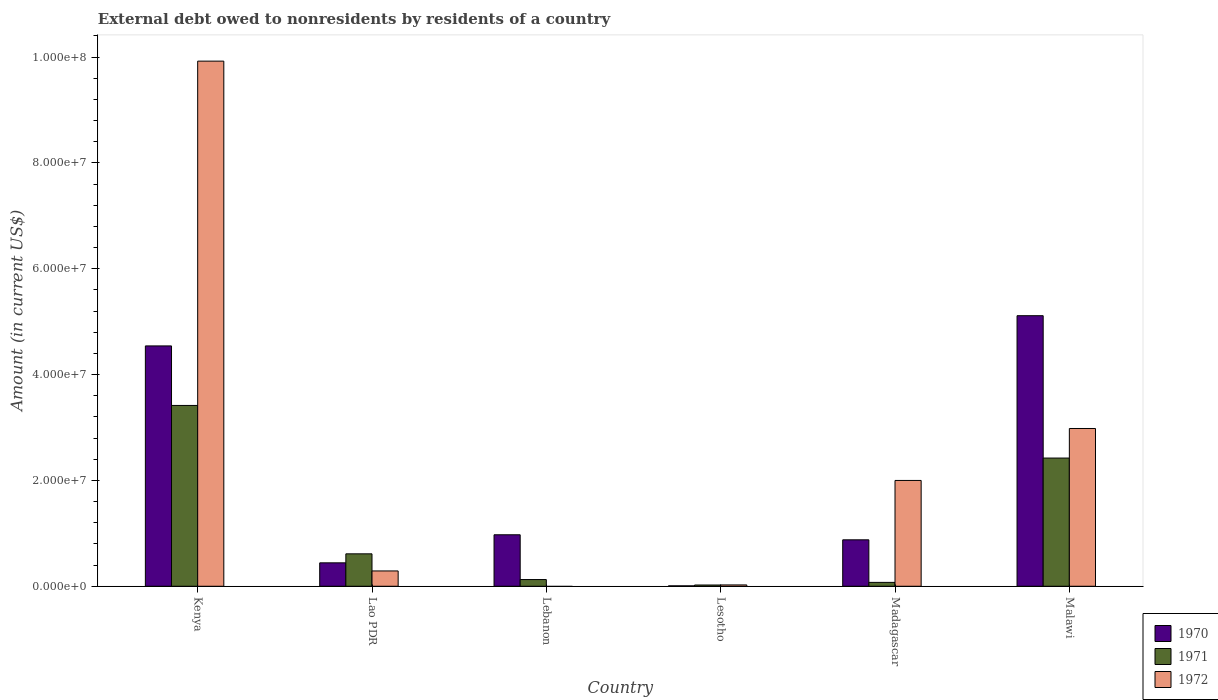Are the number of bars per tick equal to the number of legend labels?
Your answer should be compact. No. Are the number of bars on each tick of the X-axis equal?
Your answer should be compact. No. How many bars are there on the 6th tick from the left?
Offer a very short reply. 3. What is the label of the 5th group of bars from the left?
Your answer should be very brief. Madagascar. What is the external debt owed by residents in 1971 in Malawi?
Your answer should be compact. 2.42e+07. Across all countries, what is the maximum external debt owed by residents in 1972?
Your answer should be compact. 9.92e+07. Across all countries, what is the minimum external debt owed by residents in 1972?
Ensure brevity in your answer.  0. In which country was the external debt owed by residents in 1971 maximum?
Provide a short and direct response. Kenya. What is the total external debt owed by residents in 1972 in the graph?
Offer a terse response. 1.52e+08. What is the difference between the external debt owed by residents in 1970 in Lao PDR and that in Lesotho?
Offer a terse response. 4.35e+06. What is the difference between the external debt owed by residents in 1970 in Lebanon and the external debt owed by residents in 1971 in Lao PDR?
Offer a terse response. 3.60e+06. What is the average external debt owed by residents in 1970 per country?
Your answer should be very brief. 1.99e+07. What is the difference between the external debt owed by residents of/in 1972 and external debt owed by residents of/in 1970 in Malawi?
Offer a terse response. -2.13e+07. In how many countries, is the external debt owed by residents in 1971 greater than 96000000 US$?
Make the answer very short. 0. What is the ratio of the external debt owed by residents in 1971 in Lao PDR to that in Lebanon?
Offer a very short reply. 4.84. Is the external debt owed by residents in 1971 in Madagascar less than that in Malawi?
Keep it short and to the point. Yes. Is the difference between the external debt owed by residents in 1972 in Lao PDR and Malawi greater than the difference between the external debt owed by residents in 1970 in Lao PDR and Malawi?
Offer a very short reply. Yes. What is the difference between the highest and the second highest external debt owed by residents in 1972?
Provide a succinct answer. 6.94e+07. What is the difference between the highest and the lowest external debt owed by residents in 1971?
Your answer should be very brief. 3.39e+07. In how many countries, is the external debt owed by residents in 1972 greater than the average external debt owed by residents in 1972 taken over all countries?
Your answer should be compact. 2. Is the sum of the external debt owed by residents in 1971 in Lesotho and Malawi greater than the maximum external debt owed by residents in 1972 across all countries?
Make the answer very short. No. Is it the case that in every country, the sum of the external debt owed by residents in 1972 and external debt owed by residents in 1970 is greater than the external debt owed by residents in 1971?
Your answer should be very brief. Yes. How many bars are there?
Your response must be concise. 17. What is the difference between two consecutive major ticks on the Y-axis?
Your answer should be very brief. 2.00e+07. Are the values on the major ticks of Y-axis written in scientific E-notation?
Ensure brevity in your answer.  Yes. Does the graph contain any zero values?
Ensure brevity in your answer.  Yes. How are the legend labels stacked?
Offer a very short reply. Vertical. What is the title of the graph?
Your response must be concise. External debt owed to nonresidents by residents of a country. What is the label or title of the X-axis?
Offer a terse response. Country. What is the label or title of the Y-axis?
Make the answer very short. Amount (in current US$). What is the Amount (in current US$) of 1970 in Kenya?
Ensure brevity in your answer.  4.54e+07. What is the Amount (in current US$) in 1971 in Kenya?
Offer a terse response. 3.42e+07. What is the Amount (in current US$) of 1972 in Kenya?
Offer a very short reply. 9.92e+07. What is the Amount (in current US$) of 1970 in Lao PDR?
Provide a short and direct response. 4.42e+06. What is the Amount (in current US$) in 1971 in Lao PDR?
Your answer should be very brief. 6.12e+06. What is the Amount (in current US$) of 1972 in Lao PDR?
Provide a short and direct response. 2.89e+06. What is the Amount (in current US$) in 1970 in Lebanon?
Give a very brief answer. 9.73e+06. What is the Amount (in current US$) in 1971 in Lebanon?
Offer a terse response. 1.26e+06. What is the Amount (in current US$) in 1972 in Lebanon?
Provide a short and direct response. 0. What is the Amount (in current US$) in 1970 in Lesotho?
Provide a short and direct response. 7.60e+04. What is the Amount (in current US$) of 1971 in Lesotho?
Offer a terse response. 2.36e+05. What is the Amount (in current US$) of 1972 in Lesotho?
Provide a short and direct response. 2.50e+05. What is the Amount (in current US$) of 1970 in Madagascar?
Provide a short and direct response. 8.78e+06. What is the Amount (in current US$) in 1971 in Madagascar?
Your answer should be compact. 7.30e+05. What is the Amount (in current US$) in 1972 in Madagascar?
Your response must be concise. 2.00e+07. What is the Amount (in current US$) in 1970 in Malawi?
Provide a succinct answer. 5.11e+07. What is the Amount (in current US$) of 1971 in Malawi?
Give a very brief answer. 2.42e+07. What is the Amount (in current US$) in 1972 in Malawi?
Provide a short and direct response. 2.98e+07. Across all countries, what is the maximum Amount (in current US$) in 1970?
Your answer should be compact. 5.11e+07. Across all countries, what is the maximum Amount (in current US$) of 1971?
Provide a short and direct response. 3.42e+07. Across all countries, what is the maximum Amount (in current US$) in 1972?
Make the answer very short. 9.92e+07. Across all countries, what is the minimum Amount (in current US$) in 1970?
Provide a short and direct response. 7.60e+04. Across all countries, what is the minimum Amount (in current US$) in 1971?
Your response must be concise. 2.36e+05. Across all countries, what is the minimum Amount (in current US$) of 1972?
Keep it short and to the point. 0. What is the total Amount (in current US$) of 1970 in the graph?
Keep it short and to the point. 1.20e+08. What is the total Amount (in current US$) in 1971 in the graph?
Give a very brief answer. 6.67e+07. What is the total Amount (in current US$) of 1972 in the graph?
Ensure brevity in your answer.  1.52e+08. What is the difference between the Amount (in current US$) of 1970 in Kenya and that in Lao PDR?
Ensure brevity in your answer.  4.10e+07. What is the difference between the Amount (in current US$) of 1971 in Kenya and that in Lao PDR?
Your answer should be compact. 2.80e+07. What is the difference between the Amount (in current US$) in 1972 in Kenya and that in Lao PDR?
Make the answer very short. 9.63e+07. What is the difference between the Amount (in current US$) in 1970 in Kenya and that in Lebanon?
Offer a terse response. 3.57e+07. What is the difference between the Amount (in current US$) of 1971 in Kenya and that in Lebanon?
Offer a terse response. 3.29e+07. What is the difference between the Amount (in current US$) of 1970 in Kenya and that in Lesotho?
Offer a terse response. 4.53e+07. What is the difference between the Amount (in current US$) in 1971 in Kenya and that in Lesotho?
Provide a succinct answer. 3.39e+07. What is the difference between the Amount (in current US$) of 1972 in Kenya and that in Lesotho?
Offer a very short reply. 9.90e+07. What is the difference between the Amount (in current US$) in 1970 in Kenya and that in Madagascar?
Ensure brevity in your answer.  3.66e+07. What is the difference between the Amount (in current US$) in 1971 in Kenya and that in Madagascar?
Offer a terse response. 3.34e+07. What is the difference between the Amount (in current US$) in 1972 in Kenya and that in Madagascar?
Offer a terse response. 7.92e+07. What is the difference between the Amount (in current US$) in 1970 in Kenya and that in Malawi?
Your answer should be compact. -5.71e+06. What is the difference between the Amount (in current US$) in 1971 in Kenya and that in Malawi?
Your response must be concise. 9.94e+06. What is the difference between the Amount (in current US$) in 1972 in Kenya and that in Malawi?
Your response must be concise. 6.94e+07. What is the difference between the Amount (in current US$) in 1970 in Lao PDR and that in Lebanon?
Your answer should be compact. -5.30e+06. What is the difference between the Amount (in current US$) of 1971 in Lao PDR and that in Lebanon?
Make the answer very short. 4.86e+06. What is the difference between the Amount (in current US$) in 1970 in Lao PDR and that in Lesotho?
Provide a succinct answer. 4.35e+06. What is the difference between the Amount (in current US$) of 1971 in Lao PDR and that in Lesotho?
Provide a succinct answer. 5.89e+06. What is the difference between the Amount (in current US$) in 1972 in Lao PDR and that in Lesotho?
Offer a terse response. 2.64e+06. What is the difference between the Amount (in current US$) of 1970 in Lao PDR and that in Madagascar?
Provide a short and direct response. -4.35e+06. What is the difference between the Amount (in current US$) of 1971 in Lao PDR and that in Madagascar?
Provide a succinct answer. 5.39e+06. What is the difference between the Amount (in current US$) in 1972 in Lao PDR and that in Madagascar?
Offer a terse response. -1.71e+07. What is the difference between the Amount (in current US$) in 1970 in Lao PDR and that in Malawi?
Offer a very short reply. -4.67e+07. What is the difference between the Amount (in current US$) of 1971 in Lao PDR and that in Malawi?
Keep it short and to the point. -1.81e+07. What is the difference between the Amount (in current US$) in 1972 in Lao PDR and that in Malawi?
Your answer should be compact. -2.69e+07. What is the difference between the Amount (in current US$) in 1970 in Lebanon and that in Lesotho?
Make the answer very short. 9.65e+06. What is the difference between the Amount (in current US$) of 1971 in Lebanon and that in Lesotho?
Offer a terse response. 1.03e+06. What is the difference between the Amount (in current US$) of 1970 in Lebanon and that in Madagascar?
Your response must be concise. 9.51e+05. What is the difference between the Amount (in current US$) of 1971 in Lebanon and that in Madagascar?
Provide a short and direct response. 5.35e+05. What is the difference between the Amount (in current US$) of 1970 in Lebanon and that in Malawi?
Offer a very short reply. -4.14e+07. What is the difference between the Amount (in current US$) in 1971 in Lebanon and that in Malawi?
Your answer should be compact. -2.30e+07. What is the difference between the Amount (in current US$) in 1970 in Lesotho and that in Madagascar?
Your answer should be very brief. -8.70e+06. What is the difference between the Amount (in current US$) in 1971 in Lesotho and that in Madagascar?
Your answer should be very brief. -4.94e+05. What is the difference between the Amount (in current US$) of 1972 in Lesotho and that in Madagascar?
Ensure brevity in your answer.  -1.97e+07. What is the difference between the Amount (in current US$) of 1970 in Lesotho and that in Malawi?
Provide a succinct answer. -5.10e+07. What is the difference between the Amount (in current US$) of 1971 in Lesotho and that in Malawi?
Offer a terse response. -2.40e+07. What is the difference between the Amount (in current US$) of 1972 in Lesotho and that in Malawi?
Ensure brevity in your answer.  -2.96e+07. What is the difference between the Amount (in current US$) in 1970 in Madagascar and that in Malawi?
Your answer should be very brief. -4.23e+07. What is the difference between the Amount (in current US$) of 1971 in Madagascar and that in Malawi?
Your answer should be very brief. -2.35e+07. What is the difference between the Amount (in current US$) of 1972 in Madagascar and that in Malawi?
Your response must be concise. -9.82e+06. What is the difference between the Amount (in current US$) in 1970 in Kenya and the Amount (in current US$) in 1971 in Lao PDR?
Keep it short and to the point. 3.93e+07. What is the difference between the Amount (in current US$) in 1970 in Kenya and the Amount (in current US$) in 1972 in Lao PDR?
Your answer should be very brief. 4.25e+07. What is the difference between the Amount (in current US$) in 1971 in Kenya and the Amount (in current US$) in 1972 in Lao PDR?
Provide a succinct answer. 3.13e+07. What is the difference between the Amount (in current US$) in 1970 in Kenya and the Amount (in current US$) in 1971 in Lebanon?
Provide a short and direct response. 4.42e+07. What is the difference between the Amount (in current US$) in 1970 in Kenya and the Amount (in current US$) in 1971 in Lesotho?
Offer a very short reply. 4.52e+07. What is the difference between the Amount (in current US$) of 1970 in Kenya and the Amount (in current US$) of 1972 in Lesotho?
Your response must be concise. 4.52e+07. What is the difference between the Amount (in current US$) in 1971 in Kenya and the Amount (in current US$) in 1972 in Lesotho?
Your answer should be compact. 3.39e+07. What is the difference between the Amount (in current US$) of 1970 in Kenya and the Amount (in current US$) of 1971 in Madagascar?
Offer a terse response. 4.47e+07. What is the difference between the Amount (in current US$) of 1970 in Kenya and the Amount (in current US$) of 1972 in Madagascar?
Your response must be concise. 2.54e+07. What is the difference between the Amount (in current US$) in 1971 in Kenya and the Amount (in current US$) in 1972 in Madagascar?
Ensure brevity in your answer.  1.42e+07. What is the difference between the Amount (in current US$) of 1970 in Kenya and the Amount (in current US$) of 1971 in Malawi?
Provide a short and direct response. 2.12e+07. What is the difference between the Amount (in current US$) of 1970 in Kenya and the Amount (in current US$) of 1972 in Malawi?
Offer a very short reply. 1.56e+07. What is the difference between the Amount (in current US$) in 1971 in Kenya and the Amount (in current US$) in 1972 in Malawi?
Your answer should be very brief. 4.35e+06. What is the difference between the Amount (in current US$) in 1970 in Lao PDR and the Amount (in current US$) in 1971 in Lebanon?
Provide a short and direct response. 3.16e+06. What is the difference between the Amount (in current US$) in 1970 in Lao PDR and the Amount (in current US$) in 1971 in Lesotho?
Offer a very short reply. 4.19e+06. What is the difference between the Amount (in current US$) of 1970 in Lao PDR and the Amount (in current US$) of 1972 in Lesotho?
Your answer should be very brief. 4.17e+06. What is the difference between the Amount (in current US$) in 1971 in Lao PDR and the Amount (in current US$) in 1972 in Lesotho?
Your answer should be compact. 5.87e+06. What is the difference between the Amount (in current US$) in 1970 in Lao PDR and the Amount (in current US$) in 1971 in Madagascar?
Your answer should be very brief. 3.69e+06. What is the difference between the Amount (in current US$) in 1970 in Lao PDR and the Amount (in current US$) in 1972 in Madagascar?
Make the answer very short. -1.56e+07. What is the difference between the Amount (in current US$) in 1971 in Lao PDR and the Amount (in current US$) in 1972 in Madagascar?
Your answer should be compact. -1.39e+07. What is the difference between the Amount (in current US$) of 1970 in Lao PDR and the Amount (in current US$) of 1971 in Malawi?
Give a very brief answer. -1.98e+07. What is the difference between the Amount (in current US$) in 1970 in Lao PDR and the Amount (in current US$) in 1972 in Malawi?
Keep it short and to the point. -2.54e+07. What is the difference between the Amount (in current US$) of 1971 in Lao PDR and the Amount (in current US$) of 1972 in Malawi?
Your answer should be very brief. -2.37e+07. What is the difference between the Amount (in current US$) in 1970 in Lebanon and the Amount (in current US$) in 1971 in Lesotho?
Provide a short and direct response. 9.49e+06. What is the difference between the Amount (in current US$) of 1970 in Lebanon and the Amount (in current US$) of 1972 in Lesotho?
Offer a terse response. 9.48e+06. What is the difference between the Amount (in current US$) in 1971 in Lebanon and the Amount (in current US$) in 1972 in Lesotho?
Your answer should be very brief. 1.02e+06. What is the difference between the Amount (in current US$) of 1970 in Lebanon and the Amount (in current US$) of 1971 in Madagascar?
Your response must be concise. 9.00e+06. What is the difference between the Amount (in current US$) of 1970 in Lebanon and the Amount (in current US$) of 1972 in Madagascar?
Your answer should be compact. -1.03e+07. What is the difference between the Amount (in current US$) in 1971 in Lebanon and the Amount (in current US$) in 1972 in Madagascar?
Make the answer very short. -1.87e+07. What is the difference between the Amount (in current US$) in 1970 in Lebanon and the Amount (in current US$) in 1971 in Malawi?
Keep it short and to the point. -1.45e+07. What is the difference between the Amount (in current US$) of 1970 in Lebanon and the Amount (in current US$) of 1972 in Malawi?
Your response must be concise. -2.01e+07. What is the difference between the Amount (in current US$) of 1971 in Lebanon and the Amount (in current US$) of 1972 in Malawi?
Ensure brevity in your answer.  -2.85e+07. What is the difference between the Amount (in current US$) of 1970 in Lesotho and the Amount (in current US$) of 1971 in Madagascar?
Ensure brevity in your answer.  -6.54e+05. What is the difference between the Amount (in current US$) in 1970 in Lesotho and the Amount (in current US$) in 1972 in Madagascar?
Make the answer very short. -1.99e+07. What is the difference between the Amount (in current US$) in 1971 in Lesotho and the Amount (in current US$) in 1972 in Madagascar?
Offer a very short reply. -1.98e+07. What is the difference between the Amount (in current US$) of 1970 in Lesotho and the Amount (in current US$) of 1971 in Malawi?
Your response must be concise. -2.42e+07. What is the difference between the Amount (in current US$) of 1970 in Lesotho and the Amount (in current US$) of 1972 in Malawi?
Provide a succinct answer. -2.97e+07. What is the difference between the Amount (in current US$) in 1971 in Lesotho and the Amount (in current US$) in 1972 in Malawi?
Give a very brief answer. -2.96e+07. What is the difference between the Amount (in current US$) in 1970 in Madagascar and the Amount (in current US$) in 1971 in Malawi?
Give a very brief answer. -1.55e+07. What is the difference between the Amount (in current US$) of 1970 in Madagascar and the Amount (in current US$) of 1972 in Malawi?
Give a very brief answer. -2.10e+07. What is the difference between the Amount (in current US$) in 1971 in Madagascar and the Amount (in current US$) in 1972 in Malawi?
Keep it short and to the point. -2.91e+07. What is the average Amount (in current US$) of 1970 per country?
Keep it short and to the point. 1.99e+07. What is the average Amount (in current US$) of 1971 per country?
Give a very brief answer. 1.11e+07. What is the average Amount (in current US$) in 1972 per country?
Ensure brevity in your answer.  2.54e+07. What is the difference between the Amount (in current US$) in 1970 and Amount (in current US$) in 1971 in Kenya?
Offer a very short reply. 1.12e+07. What is the difference between the Amount (in current US$) of 1970 and Amount (in current US$) of 1972 in Kenya?
Keep it short and to the point. -5.38e+07. What is the difference between the Amount (in current US$) in 1971 and Amount (in current US$) in 1972 in Kenya?
Ensure brevity in your answer.  -6.51e+07. What is the difference between the Amount (in current US$) in 1970 and Amount (in current US$) in 1971 in Lao PDR?
Provide a short and direct response. -1.70e+06. What is the difference between the Amount (in current US$) of 1970 and Amount (in current US$) of 1972 in Lao PDR?
Give a very brief answer. 1.53e+06. What is the difference between the Amount (in current US$) in 1971 and Amount (in current US$) in 1972 in Lao PDR?
Provide a short and direct response. 3.23e+06. What is the difference between the Amount (in current US$) of 1970 and Amount (in current US$) of 1971 in Lebanon?
Provide a short and direct response. 8.46e+06. What is the difference between the Amount (in current US$) in 1970 and Amount (in current US$) in 1972 in Lesotho?
Offer a terse response. -1.74e+05. What is the difference between the Amount (in current US$) in 1971 and Amount (in current US$) in 1972 in Lesotho?
Your response must be concise. -1.40e+04. What is the difference between the Amount (in current US$) of 1970 and Amount (in current US$) of 1971 in Madagascar?
Offer a very short reply. 8.04e+06. What is the difference between the Amount (in current US$) in 1970 and Amount (in current US$) in 1972 in Madagascar?
Offer a very short reply. -1.12e+07. What is the difference between the Amount (in current US$) in 1971 and Amount (in current US$) in 1972 in Madagascar?
Provide a succinct answer. -1.93e+07. What is the difference between the Amount (in current US$) in 1970 and Amount (in current US$) in 1971 in Malawi?
Provide a short and direct response. 2.69e+07. What is the difference between the Amount (in current US$) of 1970 and Amount (in current US$) of 1972 in Malawi?
Your response must be concise. 2.13e+07. What is the difference between the Amount (in current US$) of 1971 and Amount (in current US$) of 1972 in Malawi?
Offer a terse response. -5.59e+06. What is the ratio of the Amount (in current US$) of 1970 in Kenya to that in Lao PDR?
Your response must be concise. 10.27. What is the ratio of the Amount (in current US$) of 1971 in Kenya to that in Lao PDR?
Offer a very short reply. 5.58. What is the ratio of the Amount (in current US$) of 1972 in Kenya to that in Lao PDR?
Provide a short and direct response. 34.31. What is the ratio of the Amount (in current US$) of 1970 in Kenya to that in Lebanon?
Your response must be concise. 4.67. What is the ratio of the Amount (in current US$) of 1971 in Kenya to that in Lebanon?
Give a very brief answer. 27.01. What is the ratio of the Amount (in current US$) of 1970 in Kenya to that in Lesotho?
Your response must be concise. 597.57. What is the ratio of the Amount (in current US$) of 1971 in Kenya to that in Lesotho?
Provide a short and direct response. 144.77. What is the ratio of the Amount (in current US$) in 1972 in Kenya to that in Lesotho?
Provide a succinct answer. 396.92. What is the ratio of the Amount (in current US$) of 1970 in Kenya to that in Madagascar?
Offer a very short reply. 5.18. What is the ratio of the Amount (in current US$) of 1971 in Kenya to that in Madagascar?
Keep it short and to the point. 46.8. What is the ratio of the Amount (in current US$) of 1972 in Kenya to that in Madagascar?
Your answer should be compact. 4.96. What is the ratio of the Amount (in current US$) in 1970 in Kenya to that in Malawi?
Your answer should be very brief. 0.89. What is the ratio of the Amount (in current US$) in 1971 in Kenya to that in Malawi?
Your answer should be compact. 1.41. What is the ratio of the Amount (in current US$) of 1972 in Kenya to that in Malawi?
Give a very brief answer. 3.33. What is the ratio of the Amount (in current US$) of 1970 in Lao PDR to that in Lebanon?
Your answer should be compact. 0.45. What is the ratio of the Amount (in current US$) in 1971 in Lao PDR to that in Lebanon?
Give a very brief answer. 4.84. What is the ratio of the Amount (in current US$) of 1970 in Lao PDR to that in Lesotho?
Keep it short and to the point. 58.21. What is the ratio of the Amount (in current US$) in 1971 in Lao PDR to that in Lesotho?
Your response must be concise. 25.95. What is the ratio of the Amount (in current US$) of 1972 in Lao PDR to that in Lesotho?
Keep it short and to the point. 11.57. What is the ratio of the Amount (in current US$) in 1970 in Lao PDR to that in Madagascar?
Your response must be concise. 0.5. What is the ratio of the Amount (in current US$) in 1971 in Lao PDR to that in Madagascar?
Make the answer very short. 8.39. What is the ratio of the Amount (in current US$) of 1972 in Lao PDR to that in Madagascar?
Your answer should be compact. 0.14. What is the ratio of the Amount (in current US$) in 1970 in Lao PDR to that in Malawi?
Keep it short and to the point. 0.09. What is the ratio of the Amount (in current US$) of 1971 in Lao PDR to that in Malawi?
Offer a terse response. 0.25. What is the ratio of the Amount (in current US$) in 1972 in Lao PDR to that in Malawi?
Provide a succinct answer. 0.1. What is the ratio of the Amount (in current US$) in 1970 in Lebanon to that in Lesotho?
Ensure brevity in your answer.  127.97. What is the ratio of the Amount (in current US$) in 1971 in Lebanon to that in Lesotho?
Ensure brevity in your answer.  5.36. What is the ratio of the Amount (in current US$) of 1970 in Lebanon to that in Madagascar?
Provide a short and direct response. 1.11. What is the ratio of the Amount (in current US$) in 1971 in Lebanon to that in Madagascar?
Your answer should be compact. 1.73. What is the ratio of the Amount (in current US$) of 1970 in Lebanon to that in Malawi?
Keep it short and to the point. 0.19. What is the ratio of the Amount (in current US$) in 1971 in Lebanon to that in Malawi?
Ensure brevity in your answer.  0.05. What is the ratio of the Amount (in current US$) in 1970 in Lesotho to that in Madagascar?
Provide a succinct answer. 0.01. What is the ratio of the Amount (in current US$) of 1971 in Lesotho to that in Madagascar?
Your response must be concise. 0.32. What is the ratio of the Amount (in current US$) in 1972 in Lesotho to that in Madagascar?
Provide a short and direct response. 0.01. What is the ratio of the Amount (in current US$) in 1970 in Lesotho to that in Malawi?
Your answer should be very brief. 0. What is the ratio of the Amount (in current US$) in 1971 in Lesotho to that in Malawi?
Ensure brevity in your answer.  0.01. What is the ratio of the Amount (in current US$) in 1972 in Lesotho to that in Malawi?
Give a very brief answer. 0.01. What is the ratio of the Amount (in current US$) of 1970 in Madagascar to that in Malawi?
Ensure brevity in your answer.  0.17. What is the ratio of the Amount (in current US$) in 1971 in Madagascar to that in Malawi?
Offer a very short reply. 0.03. What is the ratio of the Amount (in current US$) of 1972 in Madagascar to that in Malawi?
Provide a short and direct response. 0.67. What is the difference between the highest and the second highest Amount (in current US$) of 1970?
Offer a very short reply. 5.71e+06. What is the difference between the highest and the second highest Amount (in current US$) of 1971?
Your response must be concise. 9.94e+06. What is the difference between the highest and the second highest Amount (in current US$) in 1972?
Offer a terse response. 6.94e+07. What is the difference between the highest and the lowest Amount (in current US$) in 1970?
Ensure brevity in your answer.  5.10e+07. What is the difference between the highest and the lowest Amount (in current US$) in 1971?
Ensure brevity in your answer.  3.39e+07. What is the difference between the highest and the lowest Amount (in current US$) of 1972?
Your answer should be compact. 9.92e+07. 